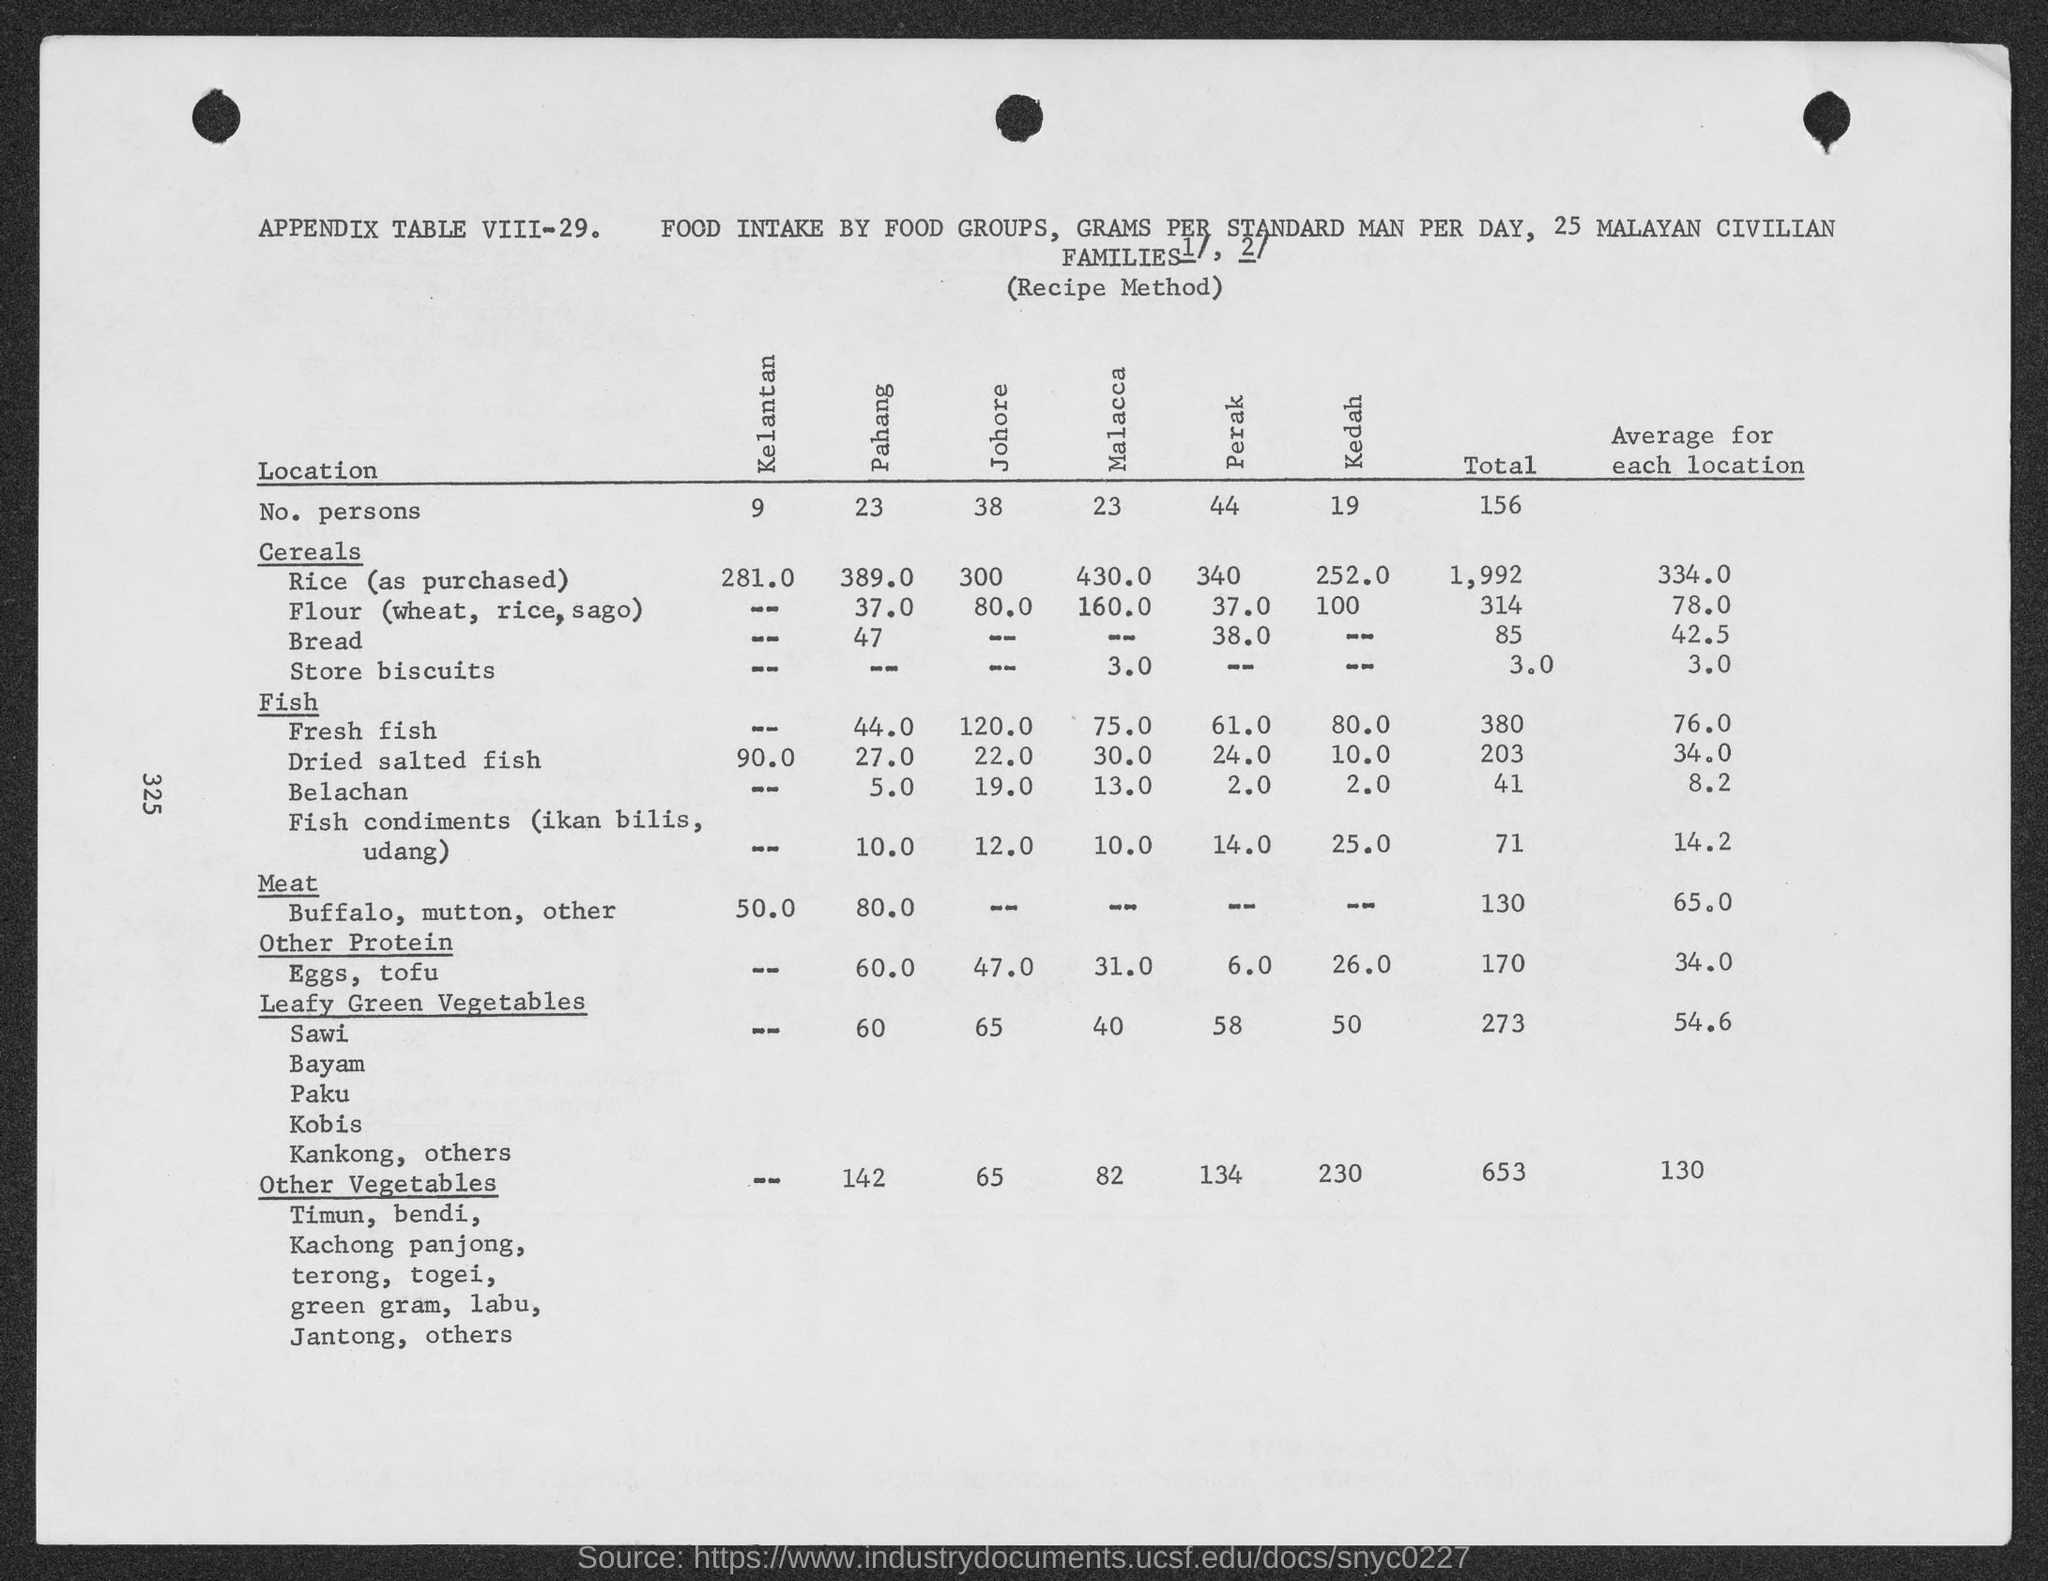Indicate a few pertinent items in this graphic. The average yield for each location under the heading "Other Vegetables" ranges from 130 to 180 MT per hectare. Leafy green vegetables have a total value of 273. 